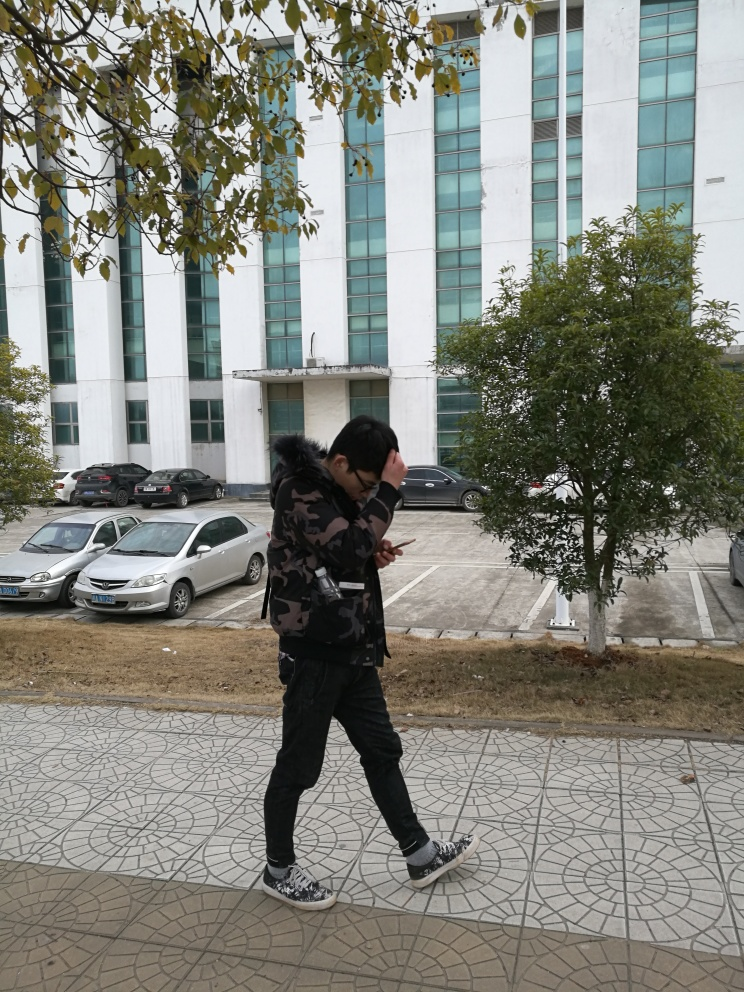Can you describe the architecture in the background? The architecture in the background features a modern, multi-story building with a series of white vertical fins. The design is minimalist, with large windows indicating it might be an office building or a public institution. 